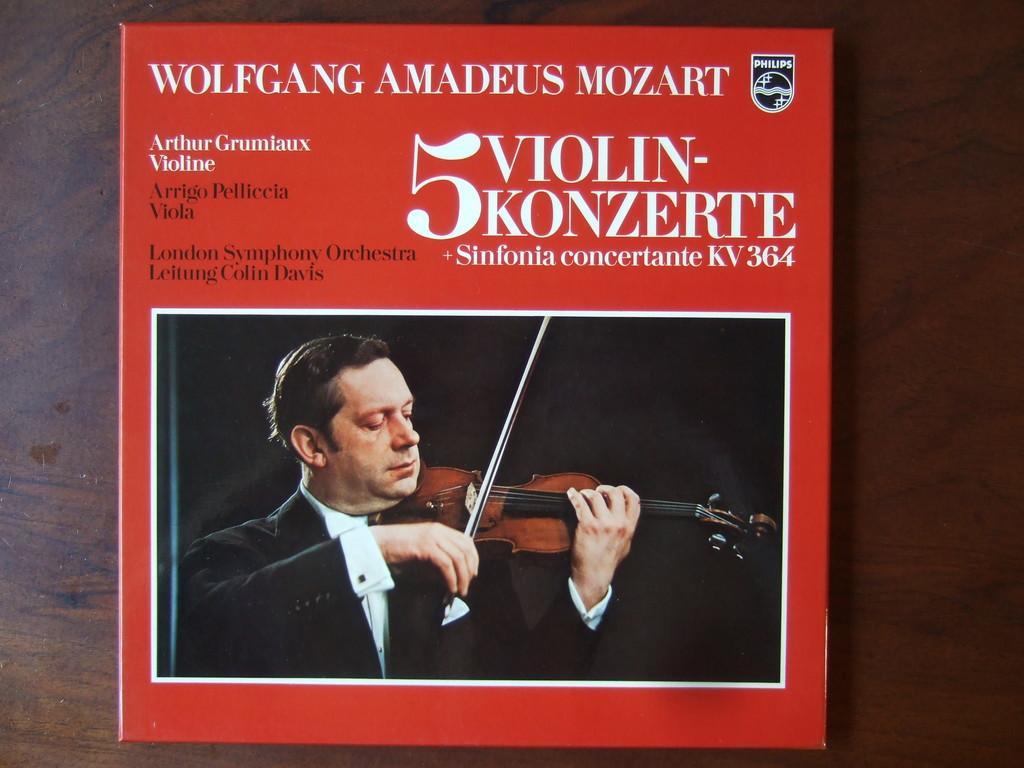In one or two sentences, can you explain what this image depicts? In this image we can see the cover page of a book. In the middle there is a man playing the violin. At the top there is some text. 